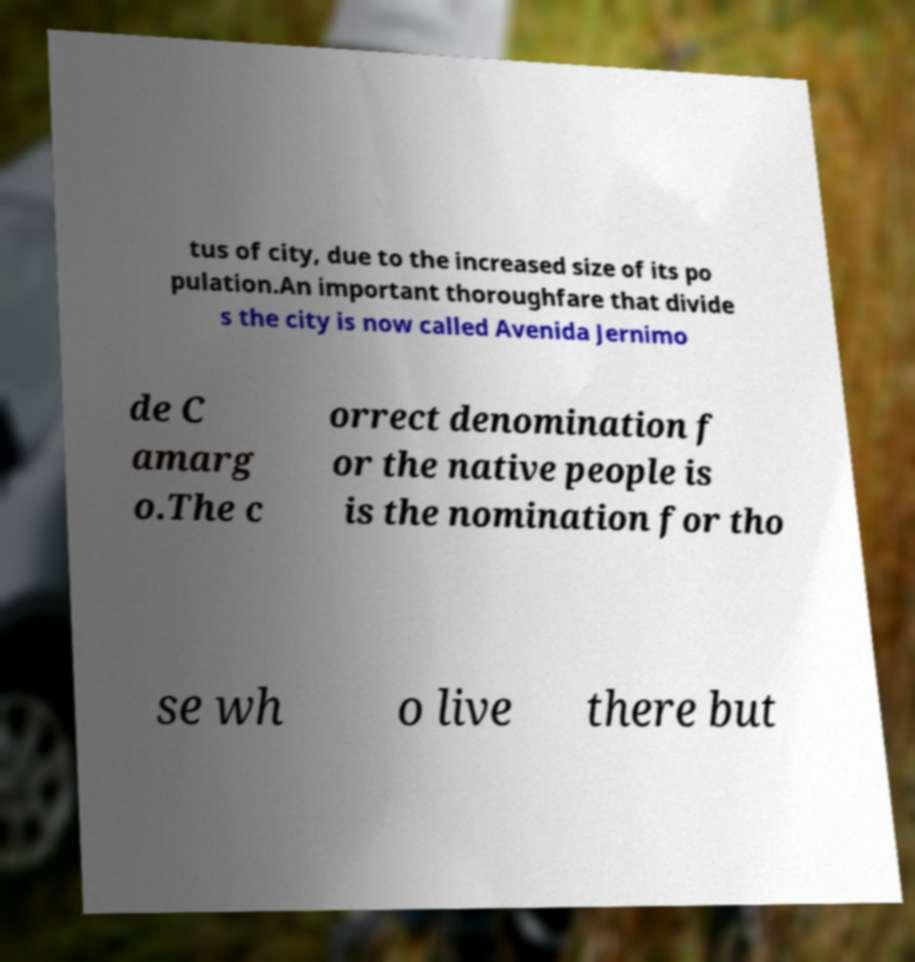There's text embedded in this image that I need extracted. Can you transcribe it verbatim? tus of city, due to the increased size of its po pulation.An important thoroughfare that divide s the city is now called Avenida Jernimo de C amarg o.The c orrect denomination f or the native people is is the nomination for tho se wh o live there but 